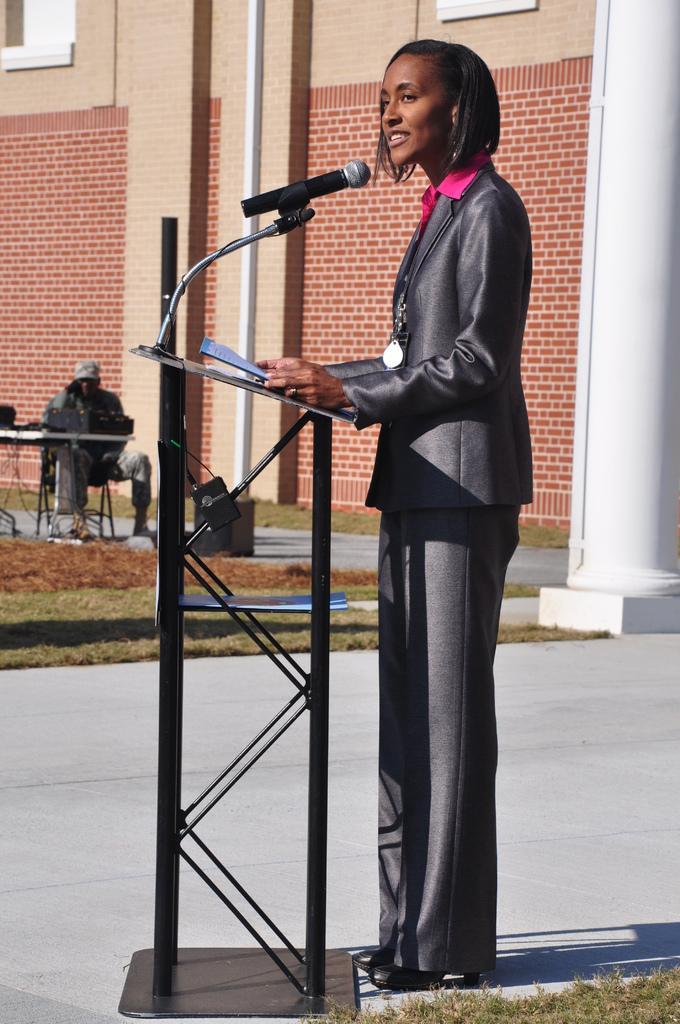Describe this image in one or two sentences. In this picture there is a woman standing and talking and she is holding the paper. There is a microphone and there is a paper on the podium. At the back there is a man sitting behind the table, there are objects on the table. There is a building and pillar. At the bottom there is an object on the pavement and there is grass. 